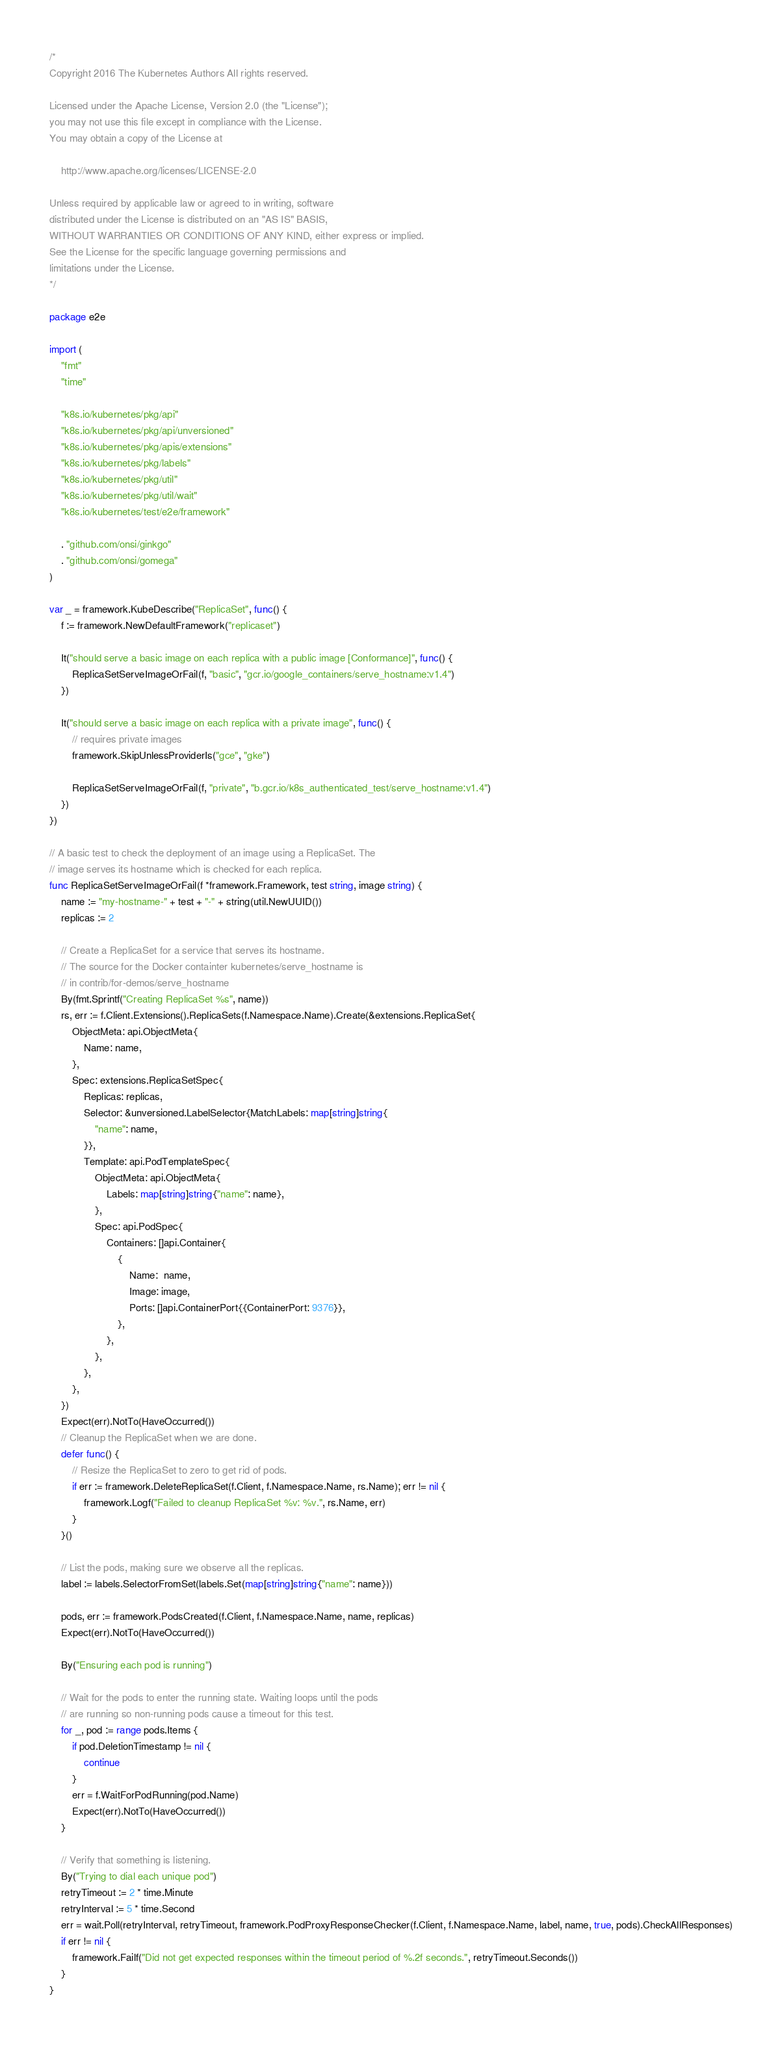Convert code to text. <code><loc_0><loc_0><loc_500><loc_500><_Go_>/*
Copyright 2016 The Kubernetes Authors All rights reserved.

Licensed under the Apache License, Version 2.0 (the "License");
you may not use this file except in compliance with the License.
You may obtain a copy of the License at

    http://www.apache.org/licenses/LICENSE-2.0

Unless required by applicable law or agreed to in writing, software
distributed under the License is distributed on an "AS IS" BASIS,
WITHOUT WARRANTIES OR CONDITIONS OF ANY KIND, either express or implied.
See the License for the specific language governing permissions and
limitations under the License.
*/

package e2e

import (
	"fmt"
	"time"

	"k8s.io/kubernetes/pkg/api"
	"k8s.io/kubernetes/pkg/api/unversioned"
	"k8s.io/kubernetes/pkg/apis/extensions"
	"k8s.io/kubernetes/pkg/labels"
	"k8s.io/kubernetes/pkg/util"
	"k8s.io/kubernetes/pkg/util/wait"
	"k8s.io/kubernetes/test/e2e/framework"

	. "github.com/onsi/ginkgo"
	. "github.com/onsi/gomega"
)

var _ = framework.KubeDescribe("ReplicaSet", func() {
	f := framework.NewDefaultFramework("replicaset")

	It("should serve a basic image on each replica with a public image [Conformance]", func() {
		ReplicaSetServeImageOrFail(f, "basic", "gcr.io/google_containers/serve_hostname:v1.4")
	})

	It("should serve a basic image on each replica with a private image", func() {
		// requires private images
		framework.SkipUnlessProviderIs("gce", "gke")

		ReplicaSetServeImageOrFail(f, "private", "b.gcr.io/k8s_authenticated_test/serve_hostname:v1.4")
	})
})

// A basic test to check the deployment of an image using a ReplicaSet. The
// image serves its hostname which is checked for each replica.
func ReplicaSetServeImageOrFail(f *framework.Framework, test string, image string) {
	name := "my-hostname-" + test + "-" + string(util.NewUUID())
	replicas := 2

	// Create a ReplicaSet for a service that serves its hostname.
	// The source for the Docker containter kubernetes/serve_hostname is
	// in contrib/for-demos/serve_hostname
	By(fmt.Sprintf("Creating ReplicaSet %s", name))
	rs, err := f.Client.Extensions().ReplicaSets(f.Namespace.Name).Create(&extensions.ReplicaSet{
		ObjectMeta: api.ObjectMeta{
			Name: name,
		},
		Spec: extensions.ReplicaSetSpec{
			Replicas: replicas,
			Selector: &unversioned.LabelSelector{MatchLabels: map[string]string{
				"name": name,
			}},
			Template: api.PodTemplateSpec{
				ObjectMeta: api.ObjectMeta{
					Labels: map[string]string{"name": name},
				},
				Spec: api.PodSpec{
					Containers: []api.Container{
						{
							Name:  name,
							Image: image,
							Ports: []api.ContainerPort{{ContainerPort: 9376}},
						},
					},
				},
			},
		},
	})
	Expect(err).NotTo(HaveOccurred())
	// Cleanup the ReplicaSet when we are done.
	defer func() {
		// Resize the ReplicaSet to zero to get rid of pods.
		if err := framework.DeleteReplicaSet(f.Client, f.Namespace.Name, rs.Name); err != nil {
			framework.Logf("Failed to cleanup ReplicaSet %v: %v.", rs.Name, err)
		}
	}()

	// List the pods, making sure we observe all the replicas.
	label := labels.SelectorFromSet(labels.Set(map[string]string{"name": name}))

	pods, err := framework.PodsCreated(f.Client, f.Namespace.Name, name, replicas)
	Expect(err).NotTo(HaveOccurred())

	By("Ensuring each pod is running")

	// Wait for the pods to enter the running state. Waiting loops until the pods
	// are running so non-running pods cause a timeout for this test.
	for _, pod := range pods.Items {
		if pod.DeletionTimestamp != nil {
			continue
		}
		err = f.WaitForPodRunning(pod.Name)
		Expect(err).NotTo(HaveOccurred())
	}

	// Verify that something is listening.
	By("Trying to dial each unique pod")
	retryTimeout := 2 * time.Minute
	retryInterval := 5 * time.Second
	err = wait.Poll(retryInterval, retryTimeout, framework.PodProxyResponseChecker(f.Client, f.Namespace.Name, label, name, true, pods).CheckAllResponses)
	if err != nil {
		framework.Failf("Did not get expected responses within the timeout period of %.2f seconds.", retryTimeout.Seconds())
	}
}
</code> 